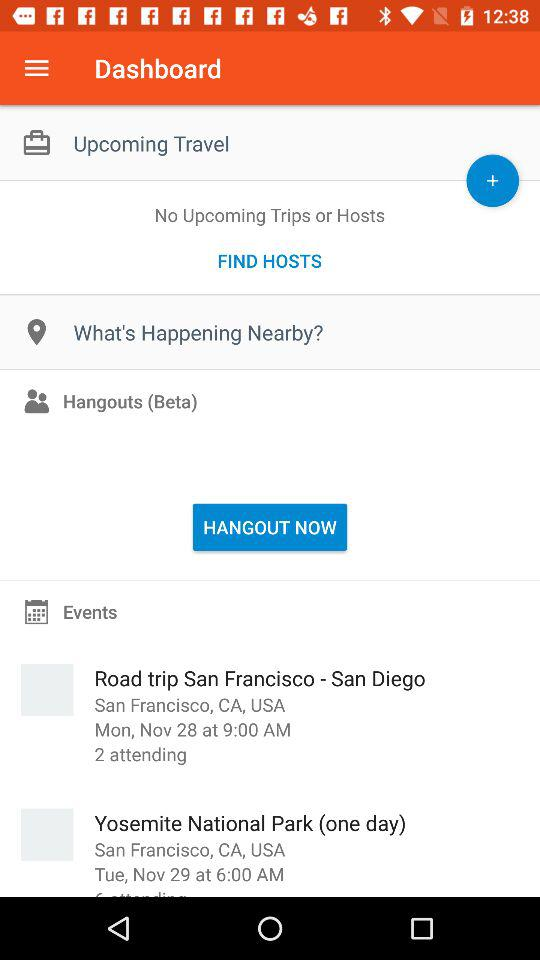What is the address of "Yosemite National Park"? The address of "Yosemite National Park" is San Francisco, CA, USA. 